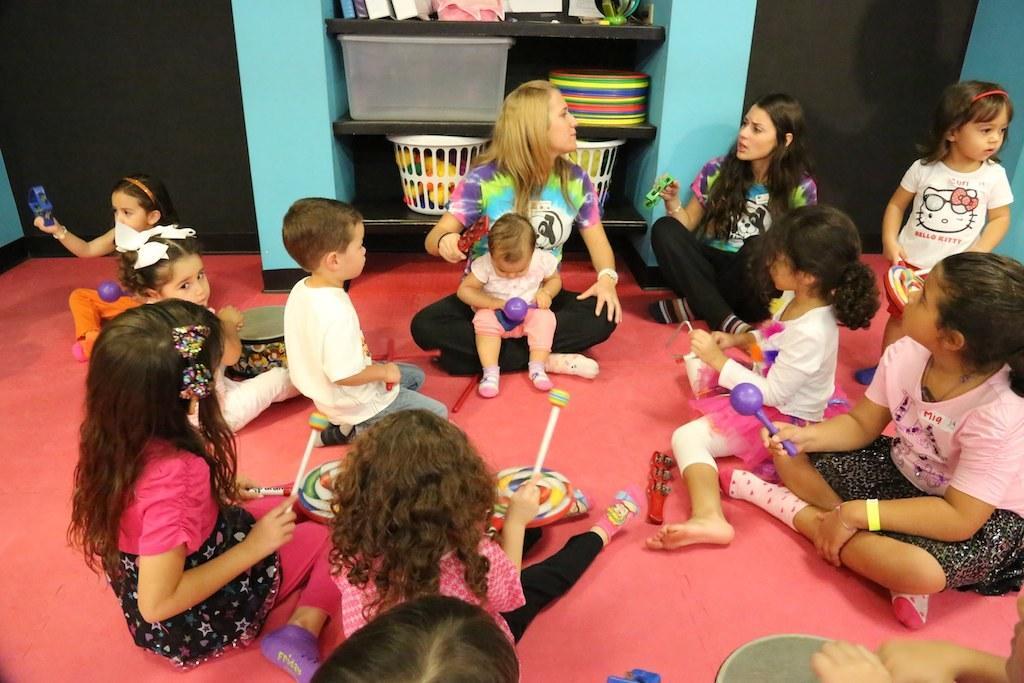Could you give a brief overview of what you see in this image? In the picture we can see inside view of the house with a red carpet and some children are sitting and playing and we can also see two women are sitting and behind them we can see a rack with something kept in it. 